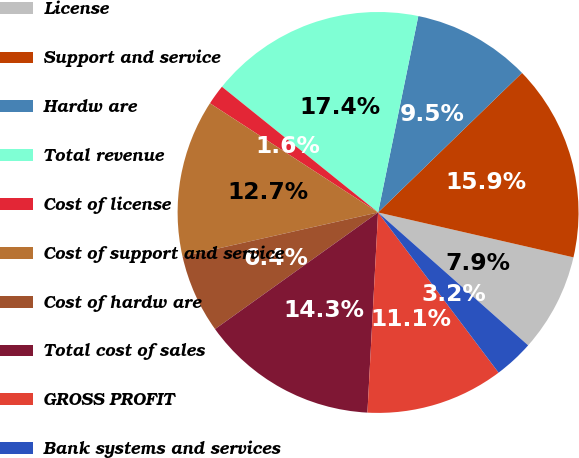<chart> <loc_0><loc_0><loc_500><loc_500><pie_chart><fcel>License<fcel>Support and service<fcel>Hardw are<fcel>Total revenue<fcel>Cost of license<fcel>Cost of support and service<fcel>Cost of hardw are<fcel>Total cost of sales<fcel>GROSS PROFIT<fcel>Bank systems and services<nl><fcel>7.94%<fcel>15.85%<fcel>9.53%<fcel>17.43%<fcel>1.62%<fcel>12.69%<fcel>6.36%<fcel>14.27%<fcel>11.11%<fcel>3.2%<nl></chart> 